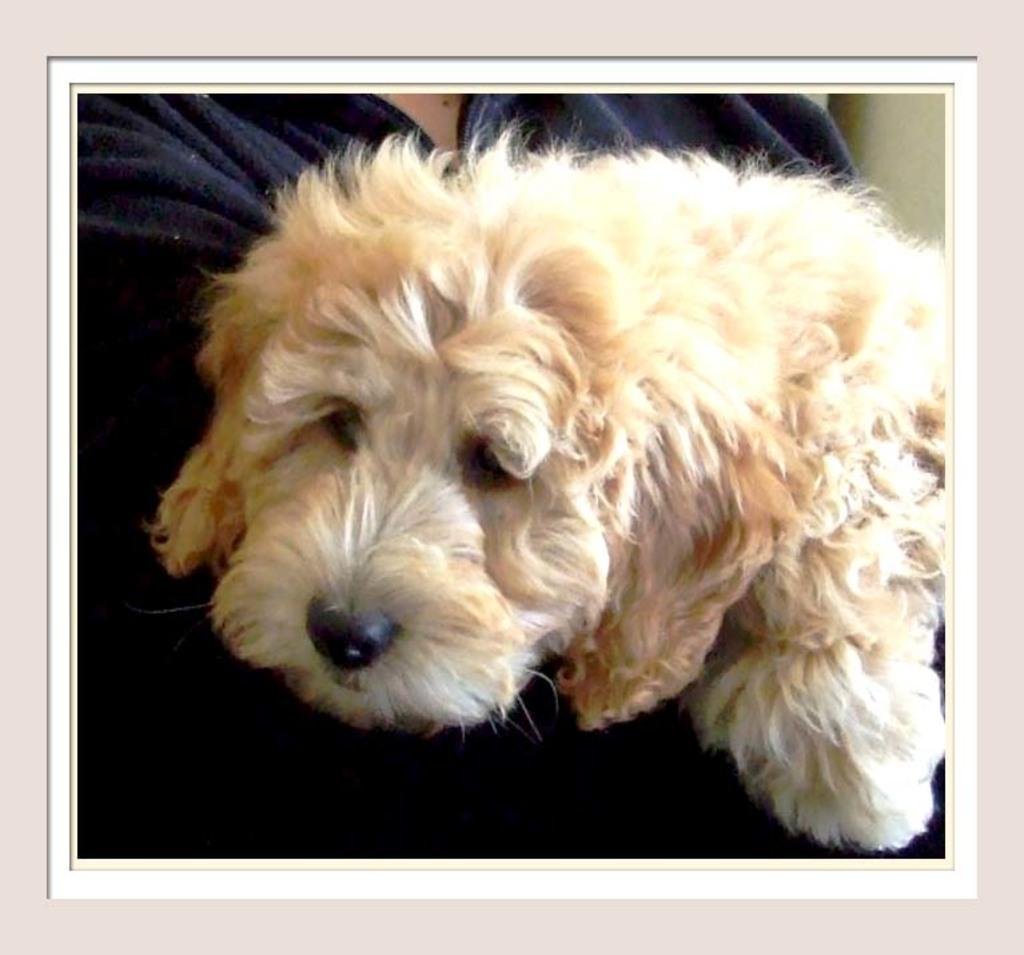What type of animal is in the image? There is a dog in the image. What is the person in the image doing with the dog? The person is holding the dog in the image. What type of insurance does the dog have in the image? There is no information about the dog's insurance in the image. 